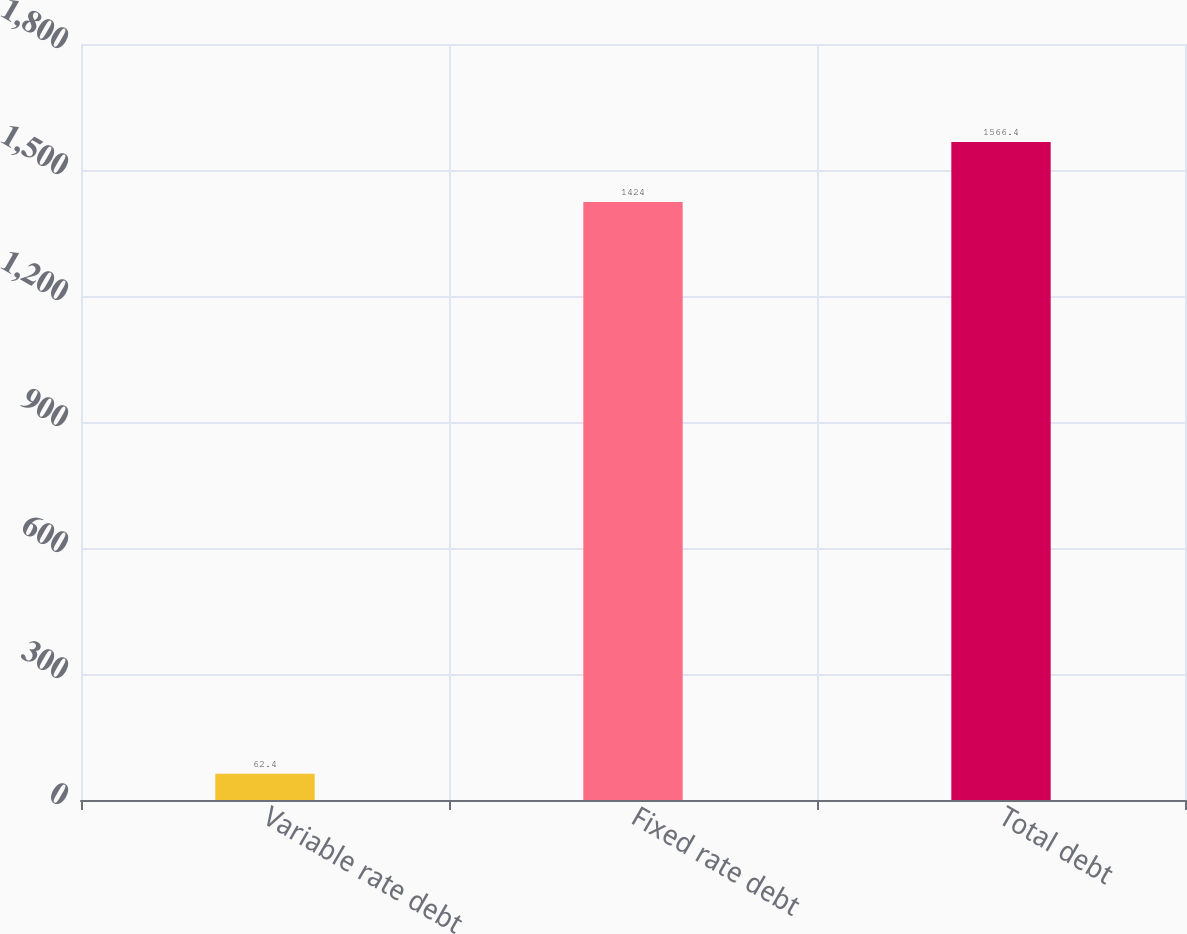Convert chart to OTSL. <chart><loc_0><loc_0><loc_500><loc_500><bar_chart><fcel>Variable rate debt<fcel>Fixed rate debt<fcel>Total debt<nl><fcel>62.4<fcel>1424<fcel>1566.4<nl></chart> 